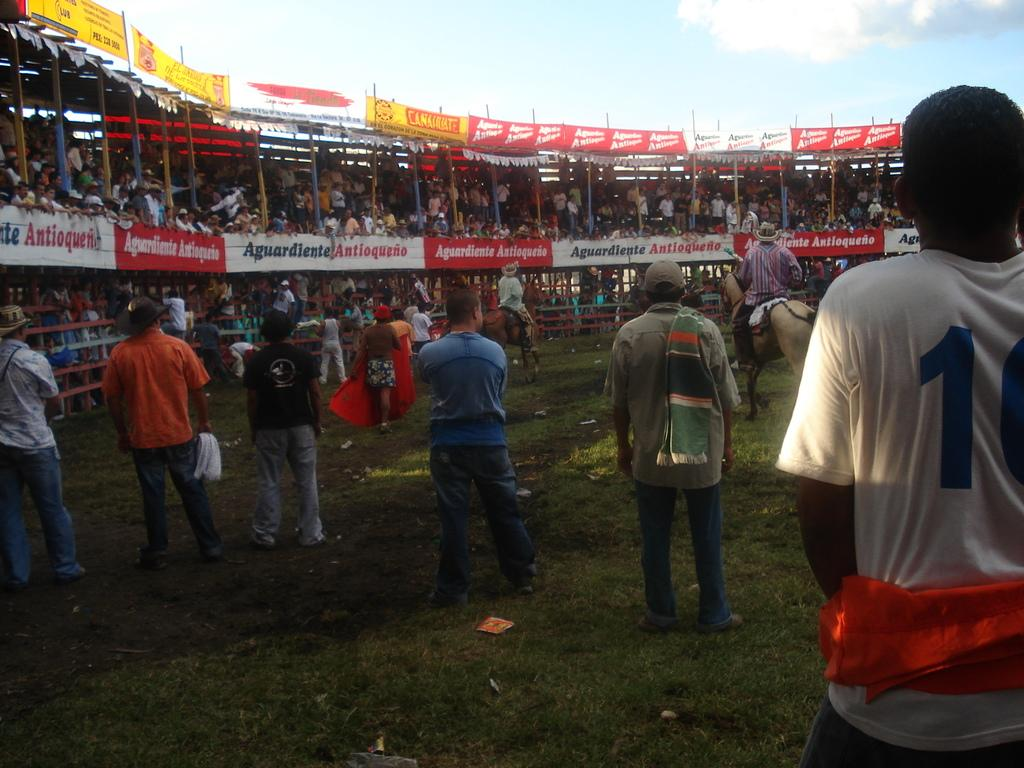What activity are the people on the ground engaged in? The people on the ground are riding horses. What can be seen in the background of the image? There are many people in the stadium in the background. What decorative elements are present in the image? There are banners in the image. How would you describe the weather based on the image? The sky is cloudy in the image. What type of wool is being used to make the volleyballs in the image? There is no mention of volleyballs or wool in the image; it features people riding horses and a stadium filled with people. 